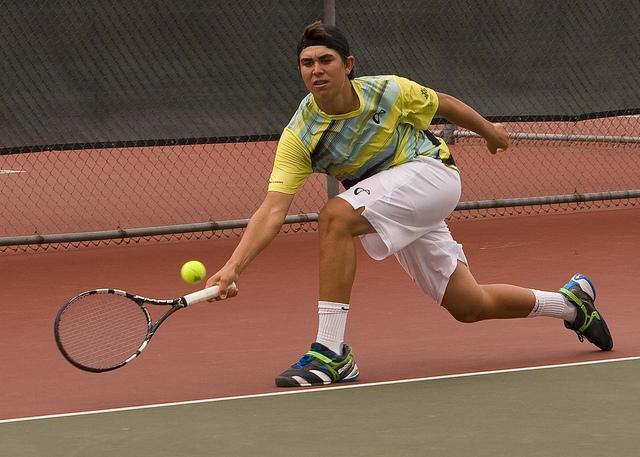How many tennis balls cast a shadow on the person?
Give a very brief answer. 0. How many dogs are there?
Give a very brief answer. 0. 